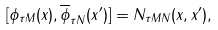Convert formula to latex. <formula><loc_0><loc_0><loc_500><loc_500>[ \phi _ { \tau M } ( x ) , \overline { \phi } _ { \tau N } ( x ^ { \prime } ) ] = N _ { \tau M N } ( x , x ^ { \prime } ) ,</formula> 